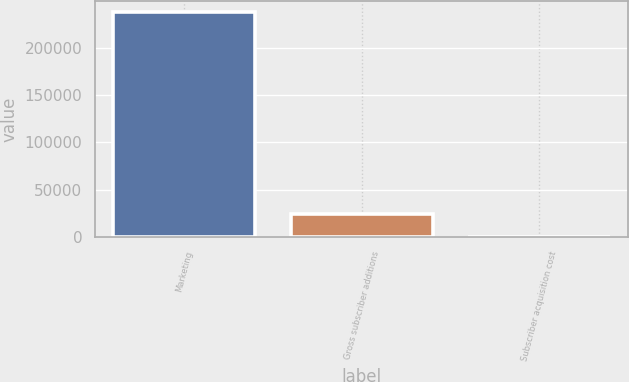Convert chart to OTSL. <chart><loc_0><loc_0><loc_500><loc_500><bar_chart><fcel>Marketing<fcel>Gross subscriber additions<fcel>Subscriber acquisition cost<nl><fcel>237744<fcel>23797.3<fcel>25.48<nl></chart> 